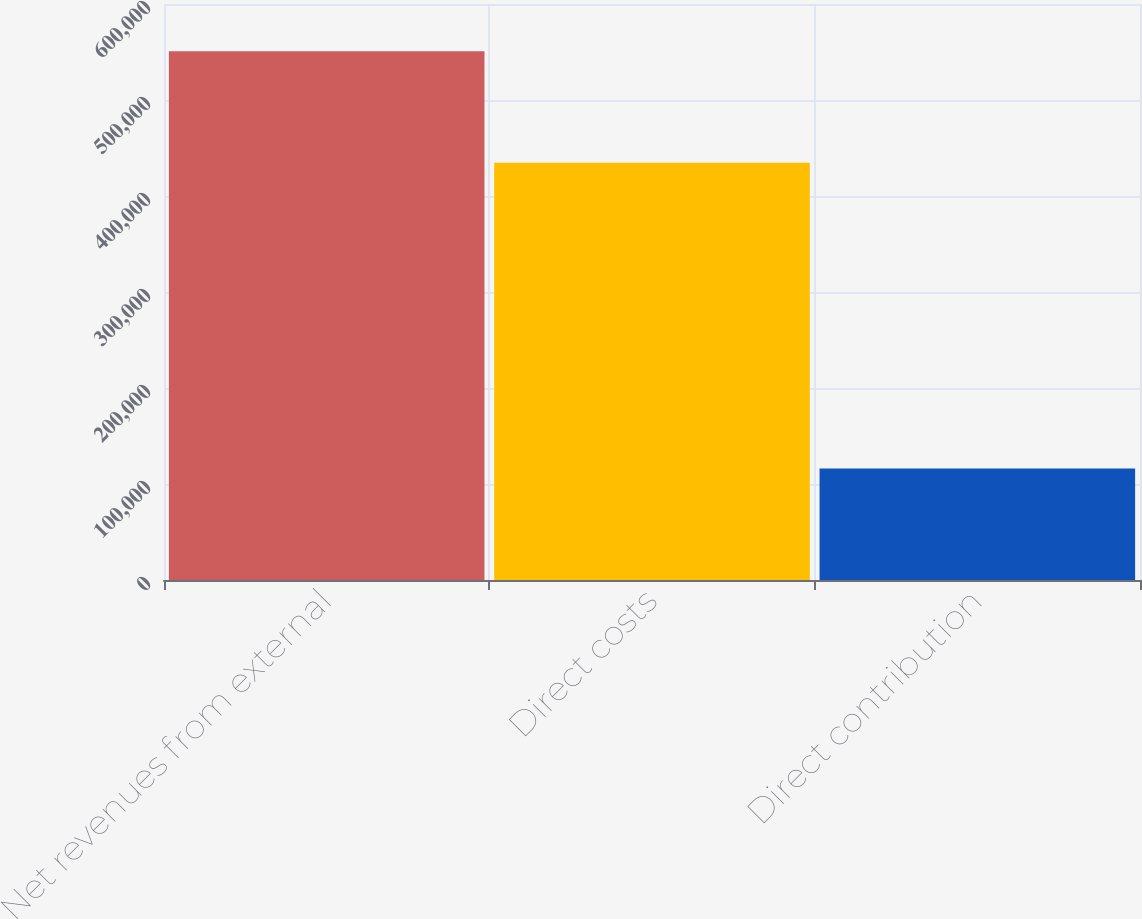Convert chart to OTSL. <chart><loc_0><loc_0><loc_500><loc_500><bar_chart><fcel>Net revenues from external<fcel>Direct costs<fcel>Direct contribution<nl><fcel>550841<fcel>434588<fcel>116253<nl></chart> 